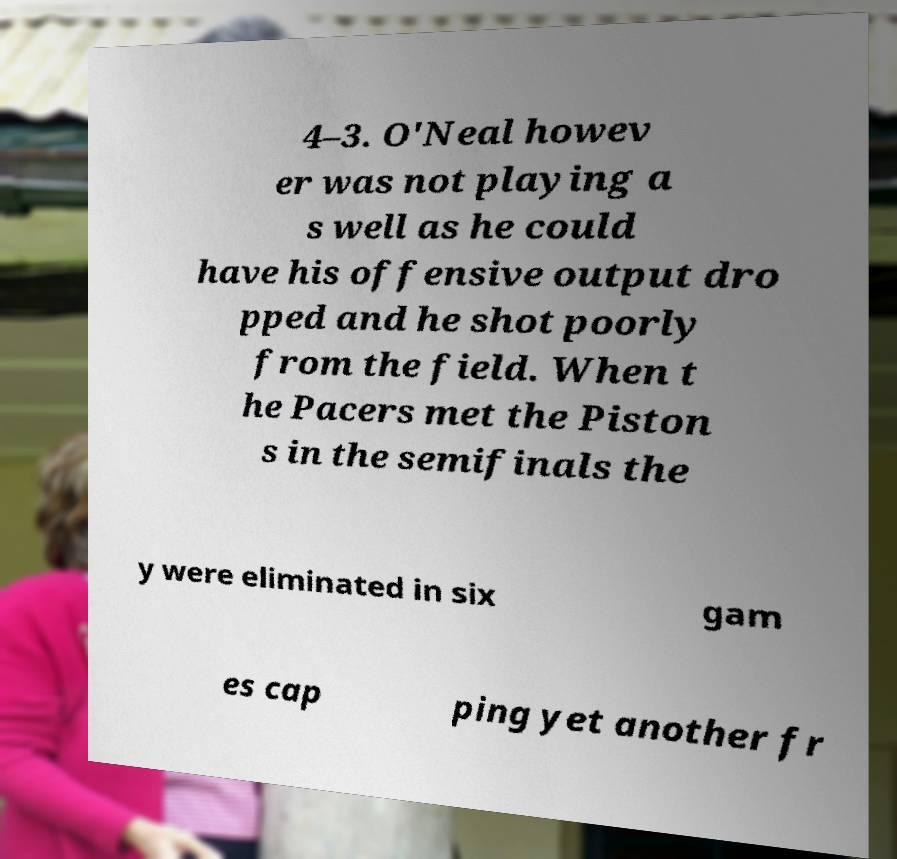Can you accurately transcribe the text from the provided image for me? 4–3. O'Neal howev er was not playing a s well as he could have his offensive output dro pped and he shot poorly from the field. When t he Pacers met the Piston s in the semifinals the y were eliminated in six gam es cap ping yet another fr 